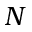Convert formula to latex. <formula><loc_0><loc_0><loc_500><loc_500>N</formula> 